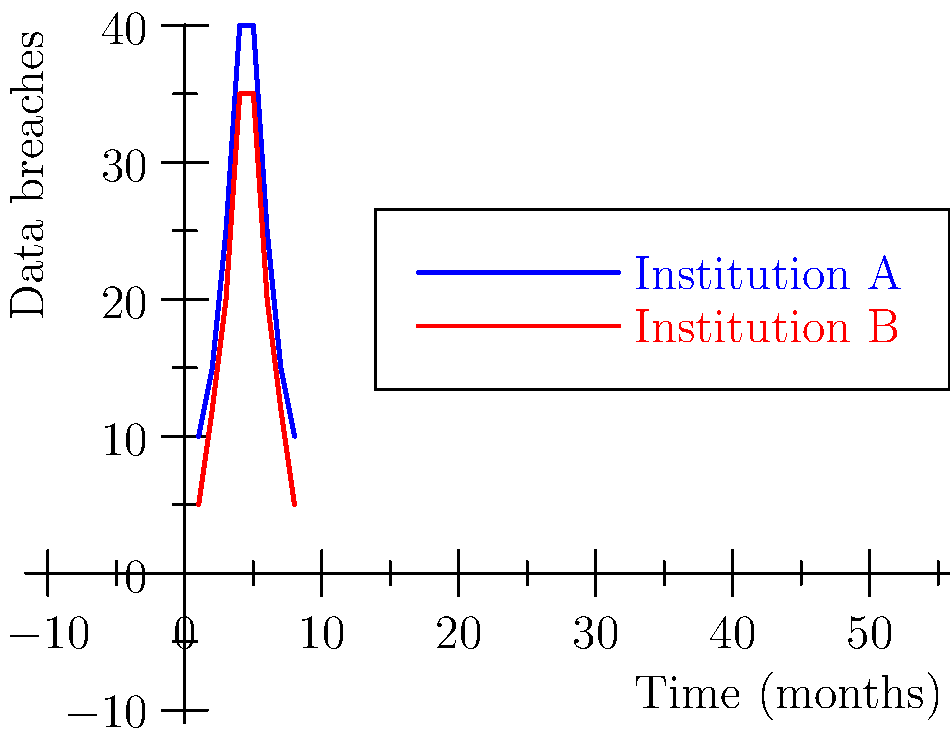Analyze the graphical representation of data breach patterns for two educational institutions over an 8-month period. Which type of symmetry is exhibited in both curves, and what does this imply about the cybersecurity trends? To identify the symmetry in the graphical representations and understand its implications for cybersecurity trends, let's follow these steps:

1. Observe the overall shape of both curves:
   - Both curves start low, rise to a peak, and then descend back to a low point.
   - The rising and falling patterns appear similar for both institutions.

2. Identify the axis of symmetry:
   - The highest point for both curves occurs at the midpoint of the x-axis (between months 4 and 5).
   - This suggests a vertical line of symmetry at this midpoint.

3. Compare left and right halves of each curve:
   - The left half (months 1-4) mirrors the right half (months 5-8) when flipped vertically.
   - This confirms the presence of mirror symmetry or reflection symmetry.

4. Analyze the symmetry type:
   - The curves demonstrate bilateral symmetry, specifically mirror symmetry about a vertical axis.

5. Interpret the cybersecurity implications:
   - The symmetrical pattern suggests a cyclical nature of data breaches.
   - There's a gradual increase in breaches, followed by a peak, and then a decrease.
   - This could indicate:
     a) A period of vulnerability discovery and exploitation (rising phase).
     b) Implementation of security measures (after the peak).
     c) Gradual resolution of vulnerabilities (falling phase).

6. Compare the two institutions:
   - Both show similar patterns, indicating common cybersecurity trends across educational institutions.
   - Institution A has consistently higher breach numbers, suggesting potentially weaker security measures or being a more attractive target.

The symmetry in these curves implies a predictable pattern in cybersecurity incidents, which can be valuable for planning and implementing proactive security measures in educational settings.
Answer: Mirror symmetry; cyclical nature of data breaches with vulnerability discovery, peak exploitation, and resolution phases. 